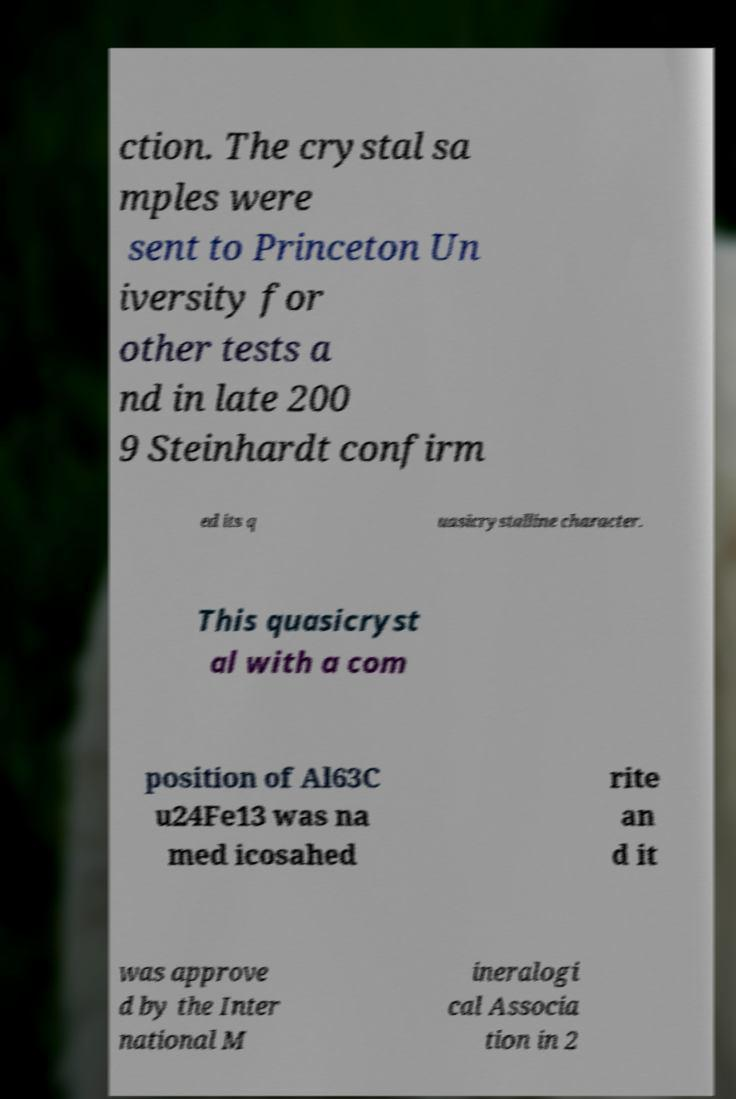Can you read and provide the text displayed in the image?This photo seems to have some interesting text. Can you extract and type it out for me? ction. The crystal sa mples were sent to Princeton Un iversity for other tests a nd in late 200 9 Steinhardt confirm ed its q uasicrystalline character. This quasicryst al with a com position of Al63C u24Fe13 was na med icosahed rite an d it was approve d by the Inter national M ineralogi cal Associa tion in 2 